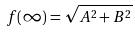<formula> <loc_0><loc_0><loc_500><loc_500>f ( \infty ) = \sqrt { A ^ { 2 } + B ^ { 2 } }</formula> 